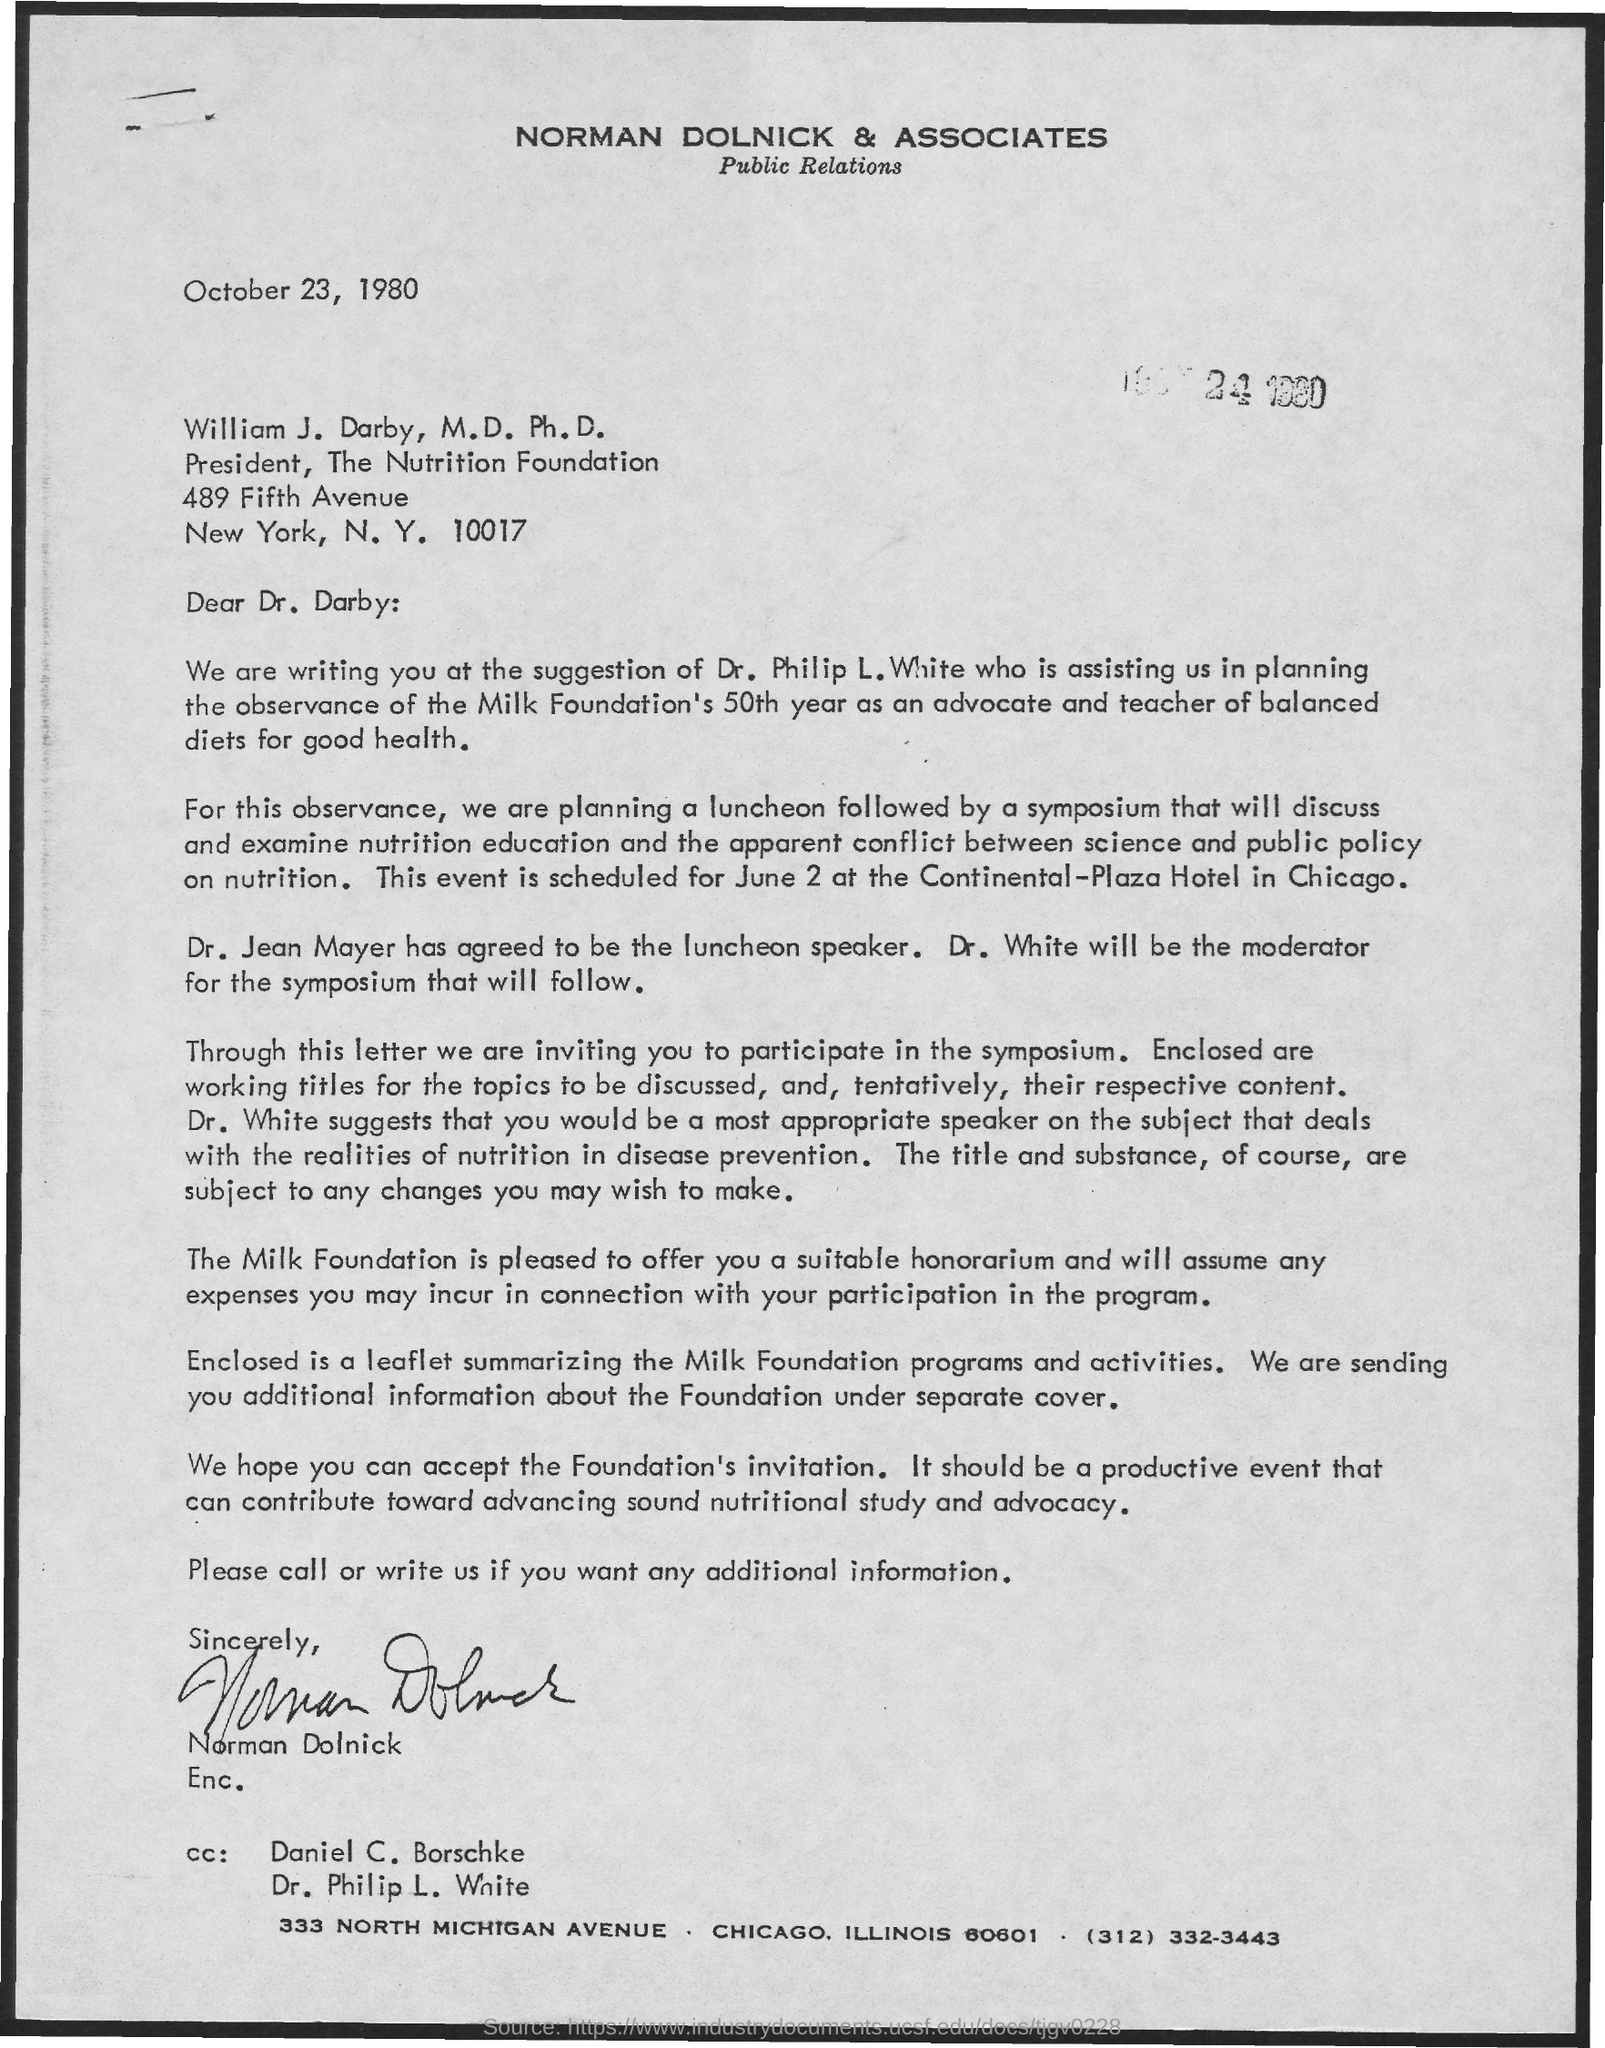What is the date on the document?
Offer a terse response. October 23, 1980. To Whom is this letter addressed to?
Provide a short and direct response. William J. Darby, M.D Ph.D. Who is the Luncheon speaker?
Your response must be concise. Dr. Jean Mayer. 